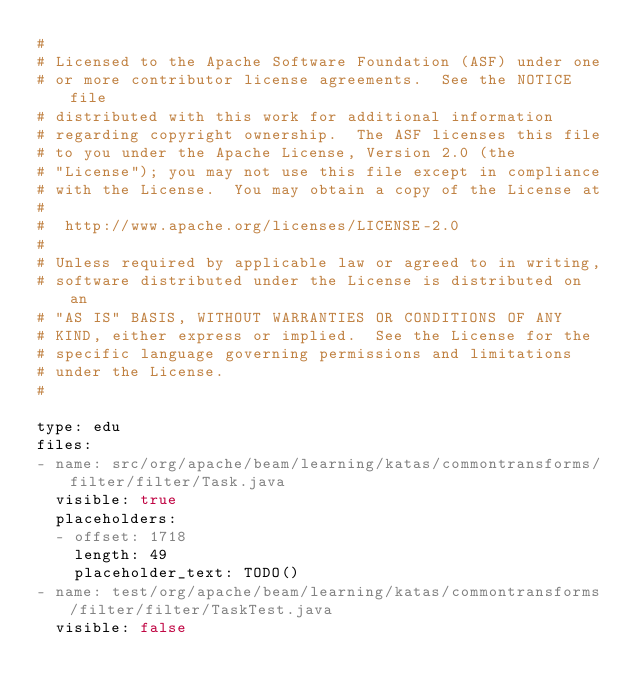<code> <loc_0><loc_0><loc_500><loc_500><_YAML_>#
# Licensed to the Apache Software Foundation (ASF) under one
# or more contributor license agreements.  See the NOTICE file
# distributed with this work for additional information
# regarding copyright ownership.  The ASF licenses this file
# to you under the Apache License, Version 2.0 (the
# "License"); you may not use this file except in compliance
# with the License.  You may obtain a copy of the License at
#
#  http://www.apache.org/licenses/LICENSE-2.0
#
# Unless required by applicable law or agreed to in writing,
# software distributed under the License is distributed on an
# "AS IS" BASIS, WITHOUT WARRANTIES OR CONDITIONS OF ANY
# KIND, either express or implied.  See the License for the
# specific language governing permissions and limitations
# under the License.
#

type: edu
files:
- name: src/org/apache/beam/learning/katas/commontransforms/filter/filter/Task.java
  visible: true
  placeholders:
  - offset: 1718
    length: 49
    placeholder_text: TODO()
- name: test/org/apache/beam/learning/katas/commontransforms/filter/filter/TaskTest.java
  visible: false
</code> 